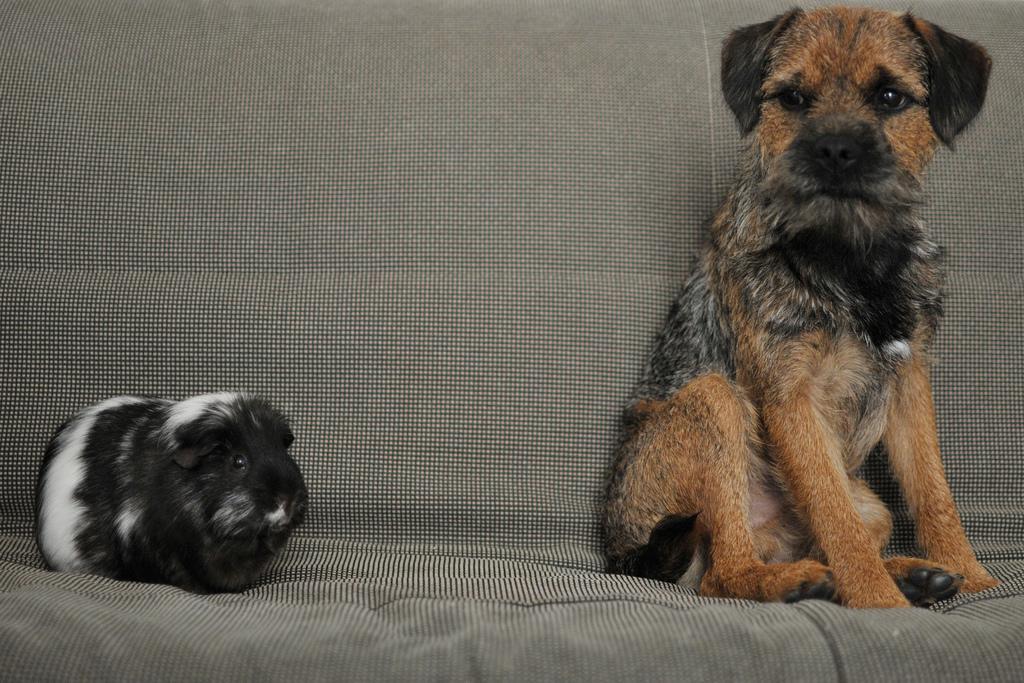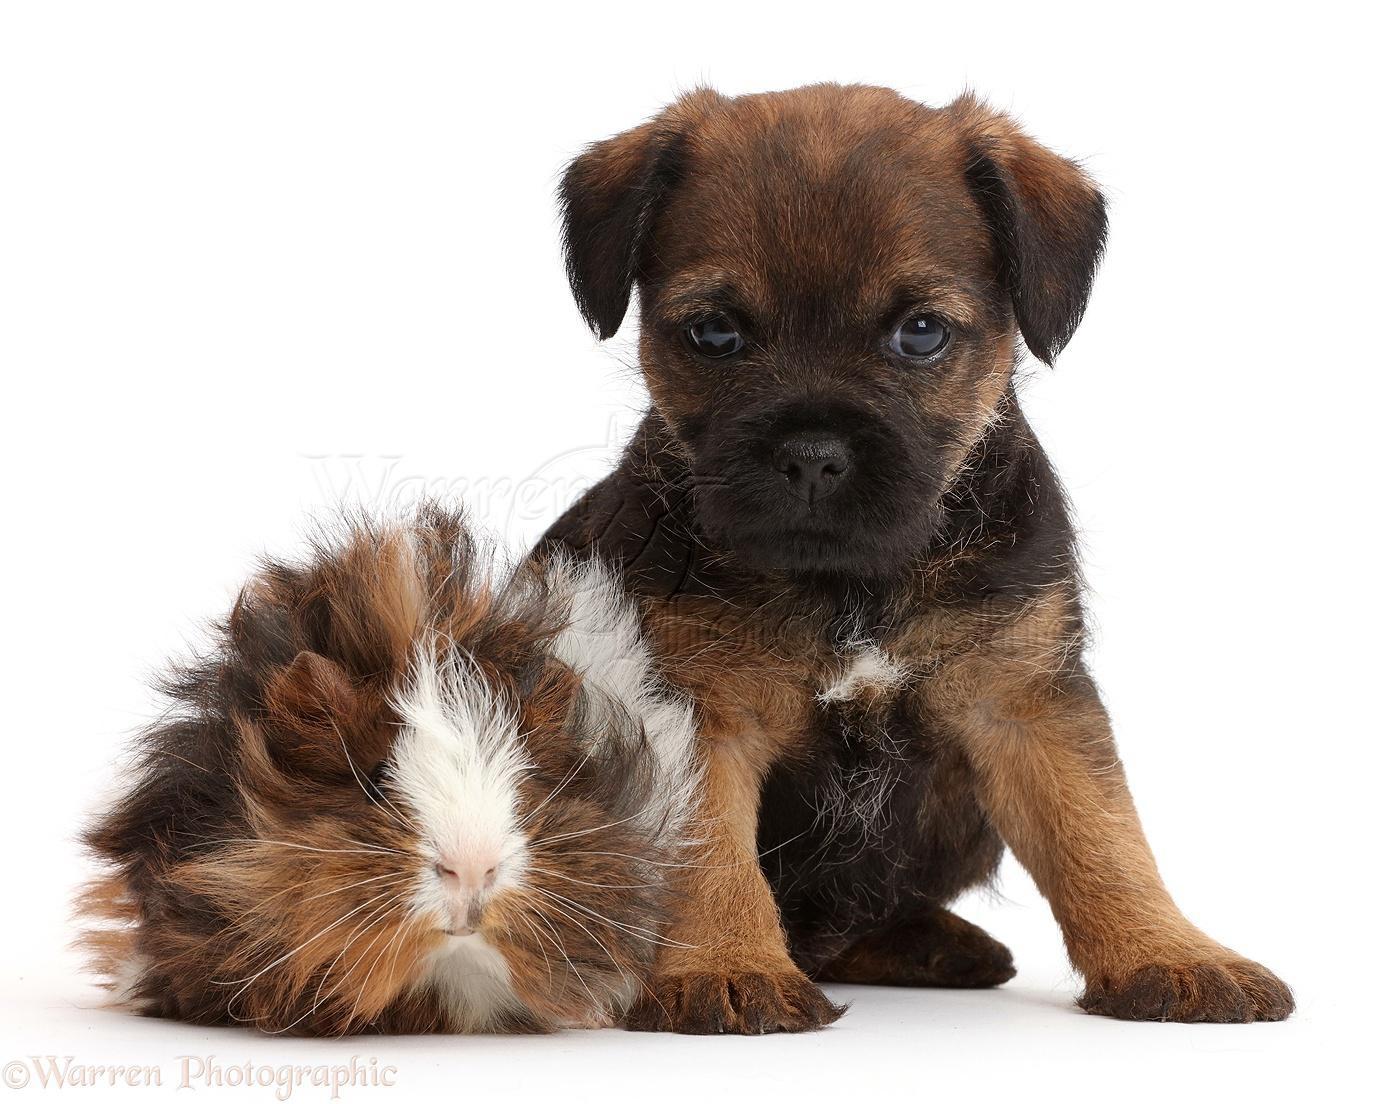The first image is the image on the left, the second image is the image on the right. Evaluate the accuracy of this statement regarding the images: "There are exactly two dogs and two guinea pigs.". Is it true? Answer yes or no. Yes. The first image is the image on the left, the second image is the image on the right. Evaluate the accuracy of this statement regarding the images: "Each image shows one guinea pig to the left of one puppy, and the right image shows a guinea pig overlapping a sitting puppy.". Is it true? Answer yes or no. Yes. 